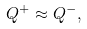Convert formula to latex. <formula><loc_0><loc_0><loc_500><loc_500>Q ^ { + } \approx Q ^ { - } ,</formula> 